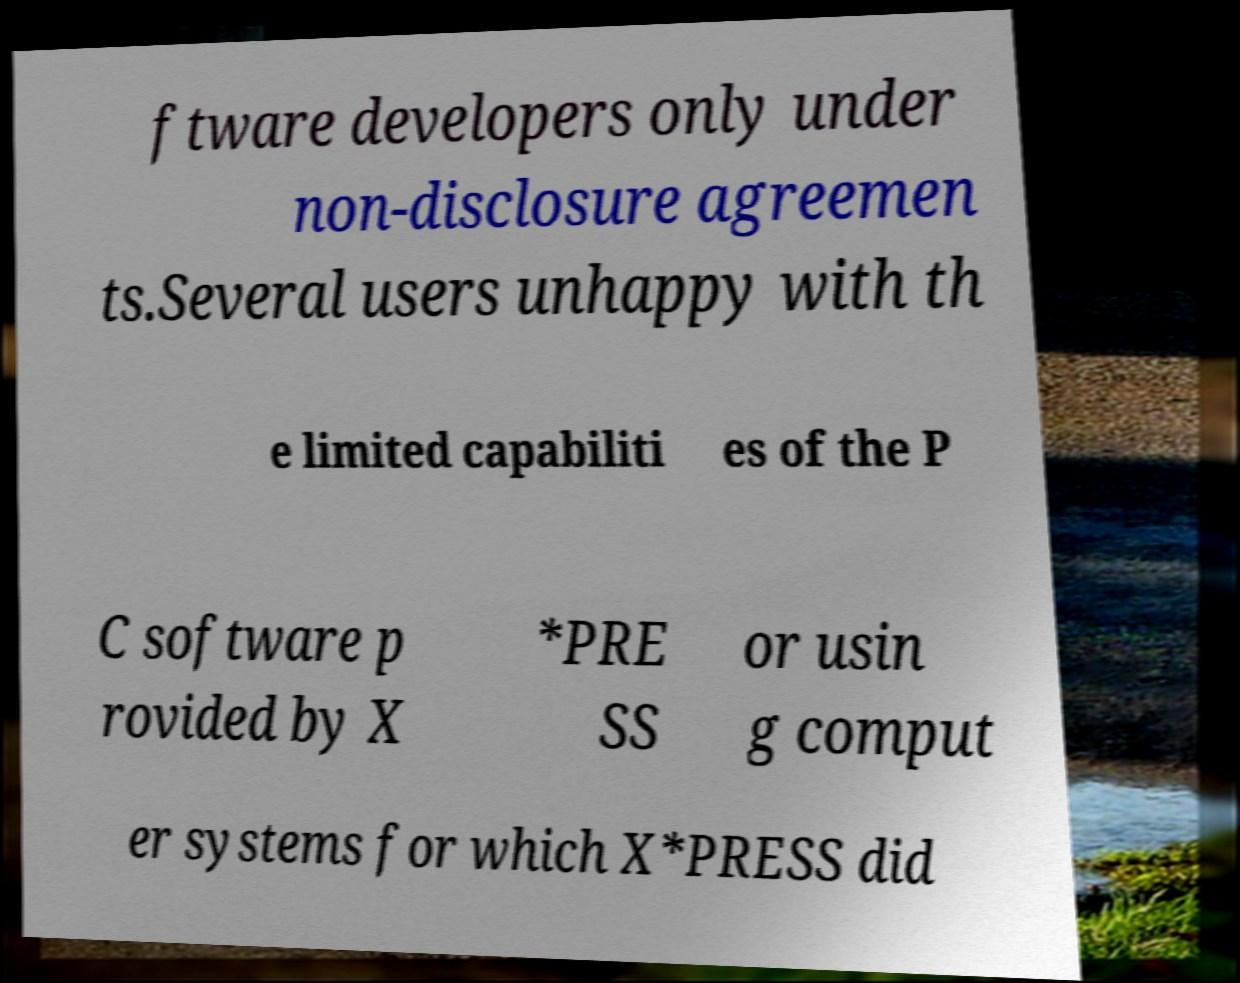There's text embedded in this image that I need extracted. Can you transcribe it verbatim? ftware developers only under non-disclosure agreemen ts.Several users unhappy with th e limited capabiliti es of the P C software p rovided by X *PRE SS or usin g comput er systems for which X*PRESS did 